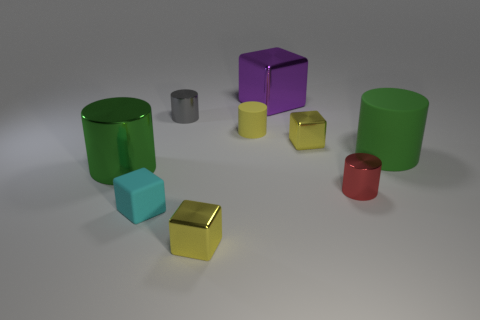What is the material of the object that is the same color as the big rubber cylinder?
Provide a succinct answer. Metal. How many red objects are small cubes or tiny matte objects?
Keep it short and to the point. 0. There is a tiny yellow shiny thing that is on the right side of the yellow metallic cube to the left of the purple thing; what shape is it?
Keep it short and to the point. Cube. Is the size of the yellow metal cube that is on the right side of the large purple block the same as the metal cylinder behind the tiny yellow matte cylinder?
Give a very brief answer. Yes. Are there any red objects made of the same material as the tiny red cylinder?
Keep it short and to the point. No. There is a small matte thing on the right side of the yellow cube to the left of the large purple shiny block; are there any small yellow rubber cylinders that are to the right of it?
Your answer should be very brief. No. There is a yellow matte thing; are there any metallic things behind it?
Your answer should be compact. Yes. What number of small cyan matte blocks are right of the big green object to the right of the large purple block?
Offer a terse response. 0. Is the size of the red metal thing the same as the green cylinder that is left of the red metallic cylinder?
Ensure brevity in your answer.  No. Is there a big metal object of the same color as the large rubber thing?
Your answer should be very brief. Yes. 